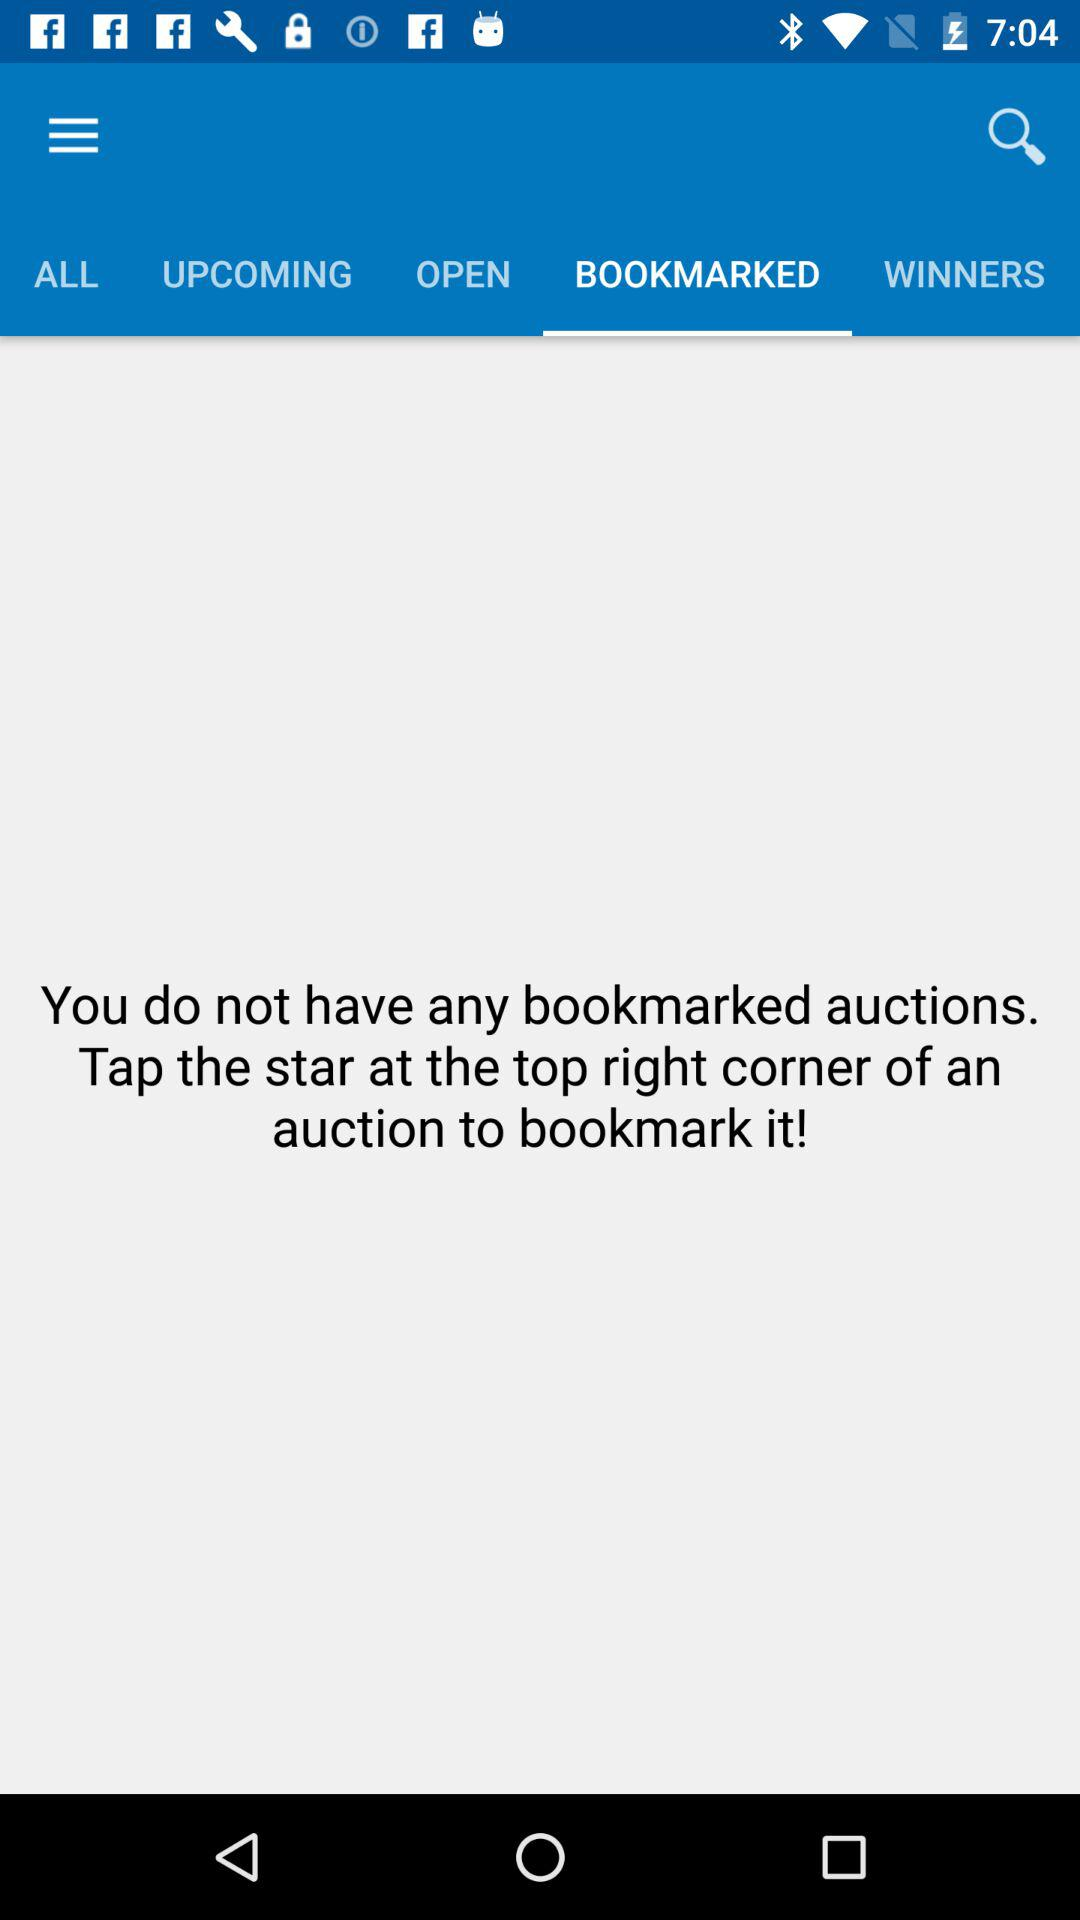How many auctions do I have bookmarked?
Answer the question using a single word or phrase. 0 